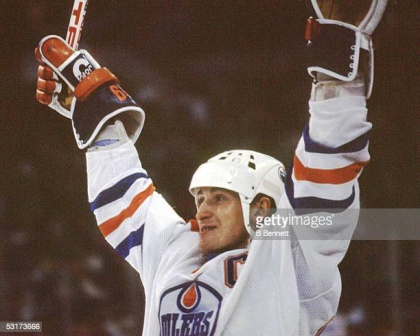Describe the following image. The image captures a jubilant moment of a hockey player from the Edmonton Oilers team, who appears to have just achieved something significant on the ice. Positioned centrally in the frame, the player wears a white jersey marked with blue and orange stripes, typical of the Oilers' team colors. His right hand firmly grips a hockey stick, and his left hand holds a glove. Both arms are uplifted in a gesture of triumph, suggesting an ecstatic celebration, possibly after scoring a goal or achieving a victory.

The backdrop of the image, while blurred, clearly sets the scene as a hockey rink, emphasizing the athletic context. The player's expression and posture embody a sense of exhilaration and pride. The overall composition highlights not just the physical prowess of the sport but also the emotional highs experienced by the players. This is a dynamic portrayal of sporting achievement, capturing both the action and the emotion of the moment. 